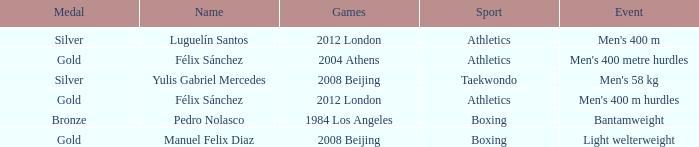Which Medal had a Name of félix sánchez, and a Games of 2012 london? Gold. 